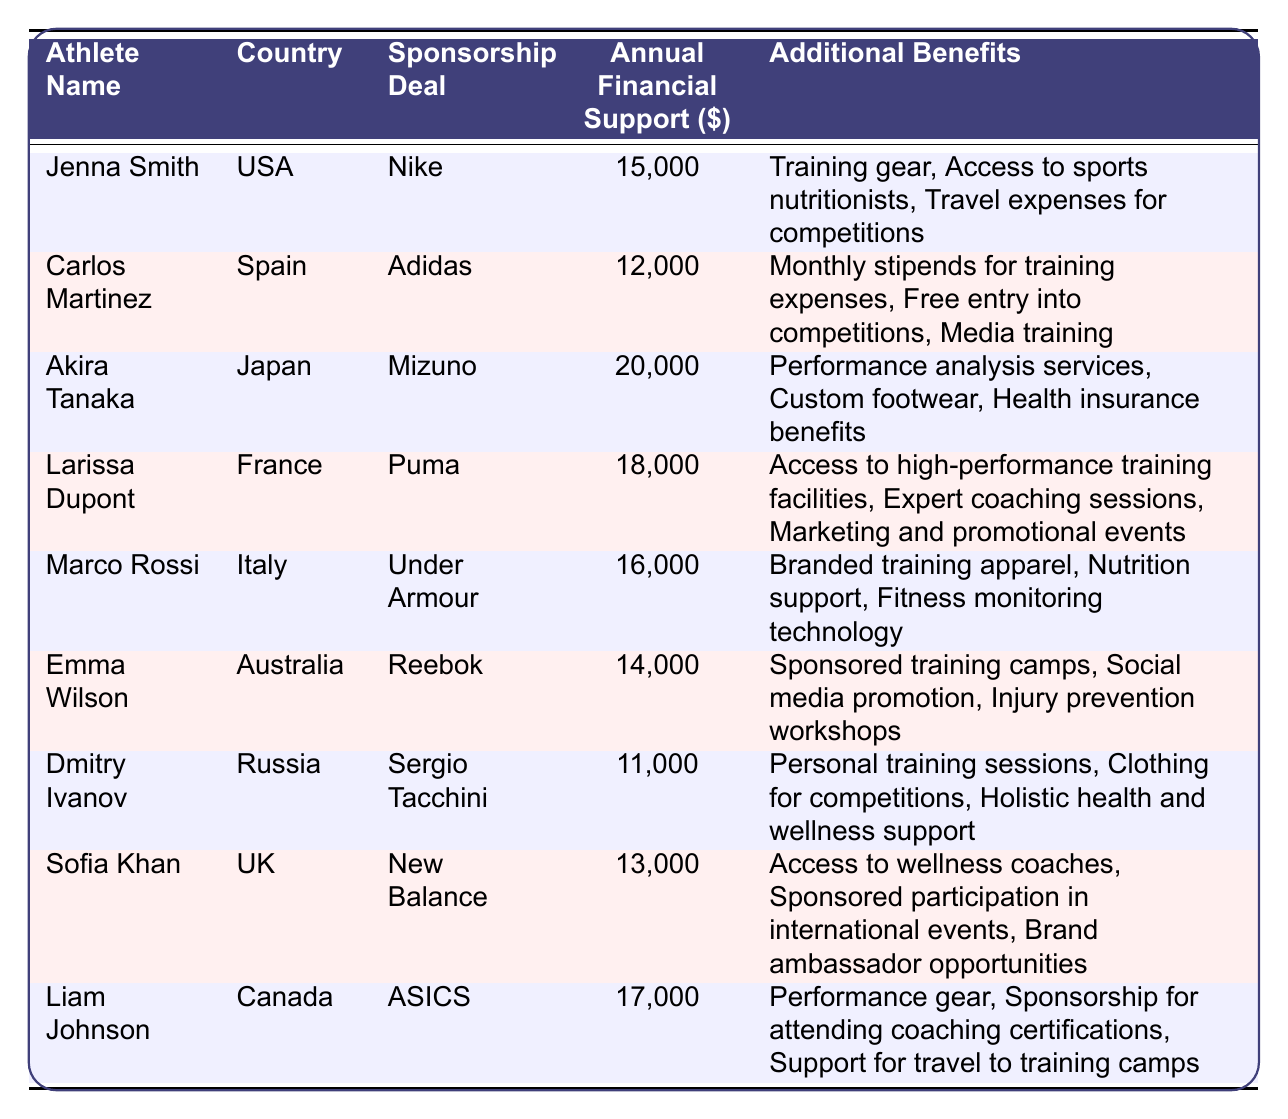What is the total annual financial support received by all athletes? To find the total, sum the annual financial support values: 15000 + 12000 + 20000 + 18000 + 16000 + 14000 + 11000 + 13000 + 17000 = 135000.
Answer: 135000 Which athlete receives the highest annual financial support? Looking at the annual financial support values, Akira Tanaka has the highest amount at 20000.
Answer: Akira Tanaka How many athletes have a sponsorship deal with Nike? The table shows only one athlete, Jenna Smith, with a sponsorship deal with Nike.
Answer: 1 Is the sponsorship deal of Liam Johnson Under Armour? The table indicates Liam Johnson has a sponsorship deal with ASICS, not Under Armour.
Answer: No What are the additional benefits provided to Carlos Martinez? Carlos Martinez receives monthly stipends for training expenses, free entry into competitions, and media training.
Answer: Monthly stipends, free entry, media training What is the average annual financial support of the athletes from Europe? The European athletes are Carlos Martinez (12000), Larissa Dupont (18000), Marco Rossi (16000), and Dmitry Ivanov (11000). The total for these athletes is 12000 + 18000 + 16000 + 11000 = 57000. There are 4 athletes, so the average is 57000 / 4 = 14250.
Answer: 14250 Which country has the athlete with the least annual financial support, and what is that amount? Dmitry Ivanov from Russia has the least annual financial support at 11000.
Answer: Russia, 11000 What is the difference in annual financial support between Akira Tanaka and Emma Wilson? Akira Tanaka receives 20000 and Emma Wilson receives 14000. The difference is 20000 - 14000 = 6000.
Answer: 6000 How many different sponsorship deals are represented in the table? The table lists nine different athletes, each with a unique sponsorship deal, making a total of nine deals.
Answer: 9 Do the athletes from North America receive more financial support on average compared to those from Asia? North American athletes are Liam Johnson (17000) and Jenna Smith (15000), with an average of (17000 + 15000) / 2 = 16000. The Asian athlete is Akira Tanaka (20000), making his support higher than the average of North America.
Answer: No 